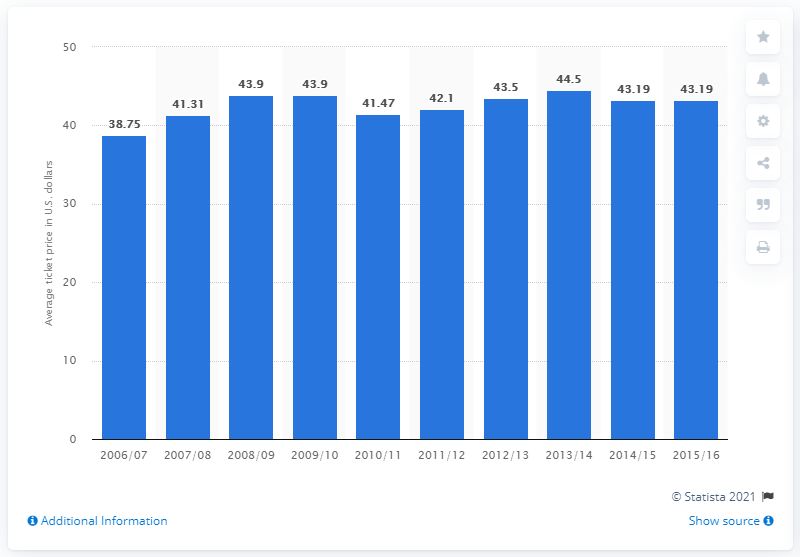Outline some significant characteristics in this image. The average ticket price for Utah Jazz games in the 2006/2007 season was $38.75. 